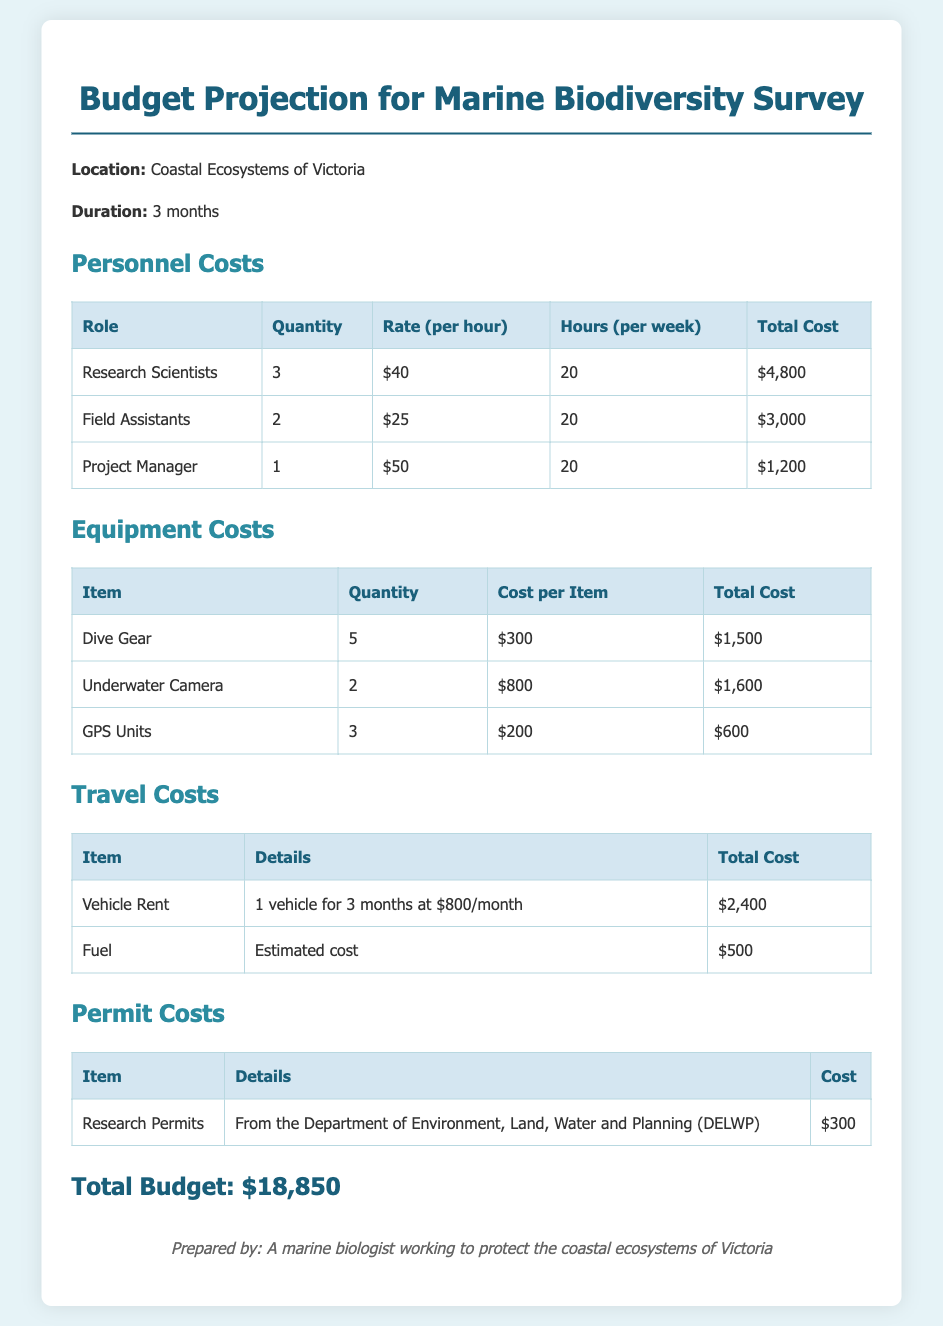What is the total budget for the marine biodiversity survey? The total budget for the marine biodiversity survey is clearly stated in the document as $18,850.
Answer: $18,850 How many research scientists are included in the personnel costs? The personnel costs section lists that there are 3 research scientists mentioned.
Answer: 3 What is the cost of the underwater camera? The equipment costs table specifies that the cost per item for the underwater camera is $800.
Answer: $800 What is the estimated fuel cost? The travel costs section indicates that the estimated fuel cost is $500.
Answer: $500 Who is responsible for preparing the budget document? The footer of the document states that it was prepared by a marine biologist working to protect the coastal ecosystems of Victoria.
Answer: A marine biologist working to protect the coastal ecosystems of Victoria How many field assistants are budgeted? The personnel costs section indicates that there are 2 field assistants included in the budget.
Answer: 2 What is the total cost for research permits? The permit costs section notes that the cost for research permits from DELWP is $300.
Answer: $300 What is the rental cost for the vehicle? In the travel costs table, it is stated that the vehicle rent is $800 per month, totaling $2,400 for 3 months.
Answer: $2,400 What is the total cost for dive gear? The equipment costs indicate that the total cost for dive gear is $1,500.
Answer: $1,500 